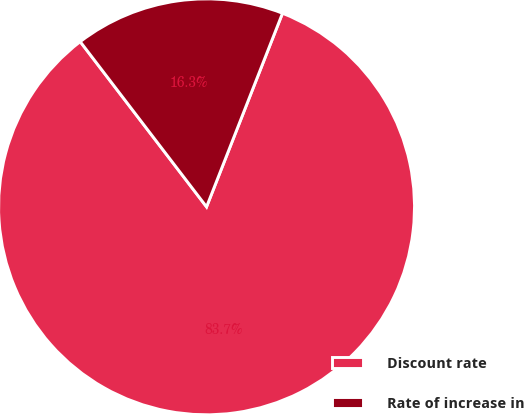<chart> <loc_0><loc_0><loc_500><loc_500><pie_chart><fcel>Discount rate<fcel>Rate of increase in<nl><fcel>83.66%<fcel>16.34%<nl></chart> 